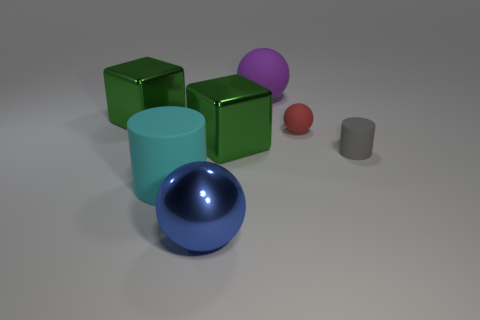Subtract all matte spheres. How many spheres are left? 1 Add 1 large metal cubes. How many objects exist? 8 Subtract 2 blocks. How many blocks are left? 0 Subtract all gray cylinders. How many cylinders are left? 1 Subtract all spheres. How many objects are left? 4 Add 6 large green metal blocks. How many large green metal blocks are left? 8 Add 4 tiny yellow matte spheres. How many tiny yellow matte spheres exist? 4 Subtract 0 green spheres. How many objects are left? 7 Subtract all blue cubes. Subtract all gray spheres. How many cubes are left? 2 Subtract all large green balls. Subtract all large purple balls. How many objects are left? 6 